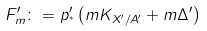<formula> <loc_0><loc_0><loc_500><loc_500>F _ { m } ^ { \prime } \colon = p ^ { \prime } _ { ^ { * } } \left ( m K _ { X ^ { \prime } / A ^ { \prime } } + m \Delta ^ { \prime } \right )</formula> 